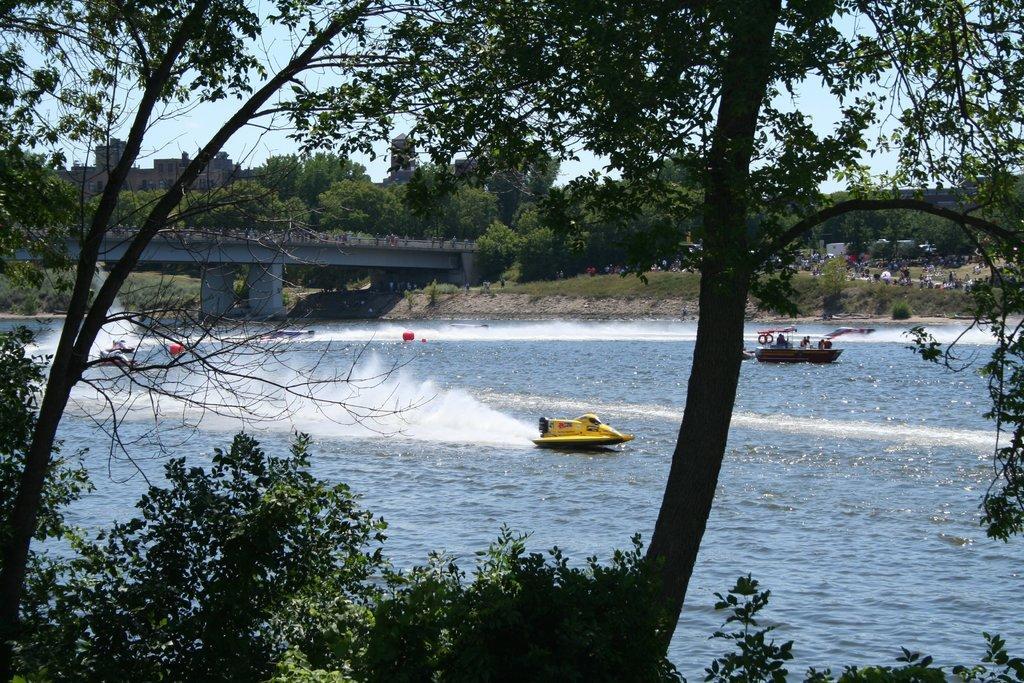Can you describe this image briefly? In this image I can see some people are riding boats on the water surface, around I can see some trees, plants, bridge and grass. 